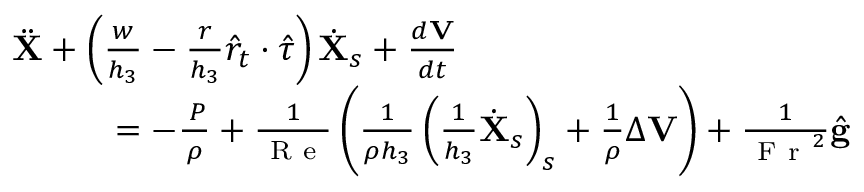Convert formula to latex. <formula><loc_0><loc_0><loc_500><loc_500>\begin{array} { r } { \ddot { X } + \left ( \frac { w } { h _ { 3 } } - \frac { r } { h _ { 3 } } \hat { r } _ { t } \cdot \hat { \tau } \right ) \dot { X } _ { s } + \frac { d V } { d t } \quad } \\ { = - \frac { \nabla P } { \rho } + \frac { 1 } { R e } \left ( \frac { 1 } { \rho h _ { 3 } } \left ( \frac { 1 } { h _ { 3 } } \dot { X } _ { s } \right ) _ { s } + \frac { 1 } { \rho } \Delta V \right ) + \frac { 1 } { F r ^ { 2 } } \hat { g } } \end{array}</formula> 